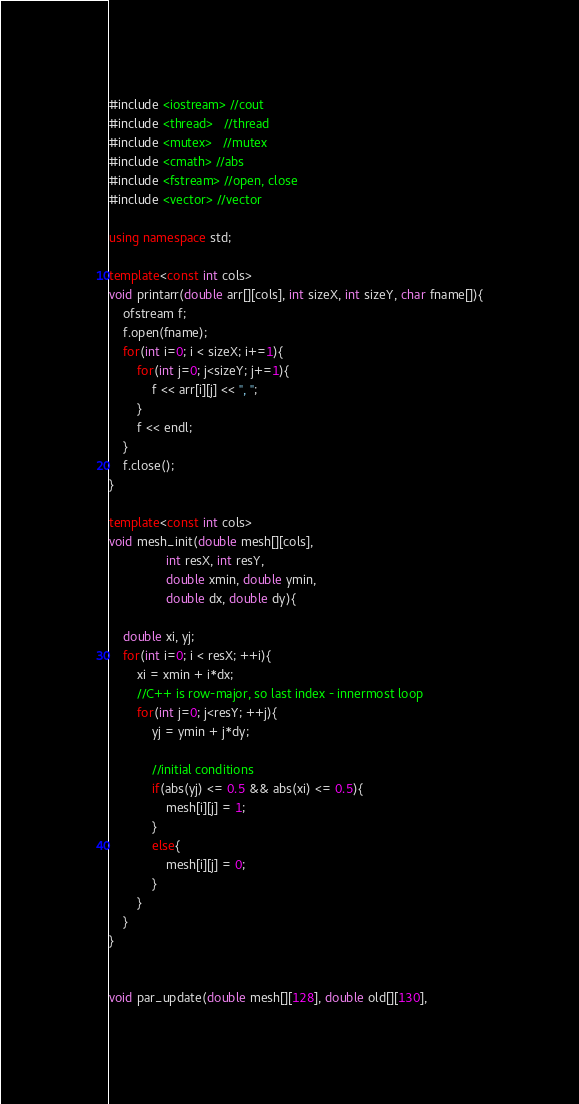Convert code to text. <code><loc_0><loc_0><loc_500><loc_500><_C++_>#include <iostream> //cout
#include <thread>   //thread
#include <mutex>   //mutex
#include <cmath> //abs
#include <fstream> //open, close
#include <vector> //vector

using namespace std;

template<const int cols>
void printarr(double arr[][cols], int sizeX, int sizeY, char fname[]){
    ofstream f;
    f.open(fname);
    for(int i=0; i < sizeX; i+=1){
        for(int j=0; j<sizeY; j+=1){
            f << arr[i][j] << ", ";
        }
        f << endl;
    }
    f.close();
}

template<const int cols>
void mesh_init(double mesh[][cols],
                int resX, int resY,
                double xmin, double ymin,
                double dx, double dy){

    double xi, yj;
    for(int i=0; i < resX; ++i){
        xi = xmin + i*dx;
        //C++ is row-major, so last index - innermost loop
        for(int j=0; j<resY; ++j){
            yj = ymin + j*dy;

            //initial conditions
            if(abs(yj) <= 0.5 && abs(xi) <= 0.5){
                mesh[i][j] = 1;
            }
            else{
                mesh[i][j] = 0;
            }
        }
    }
}


void par_update(double mesh[][128], double old[][130],</code> 